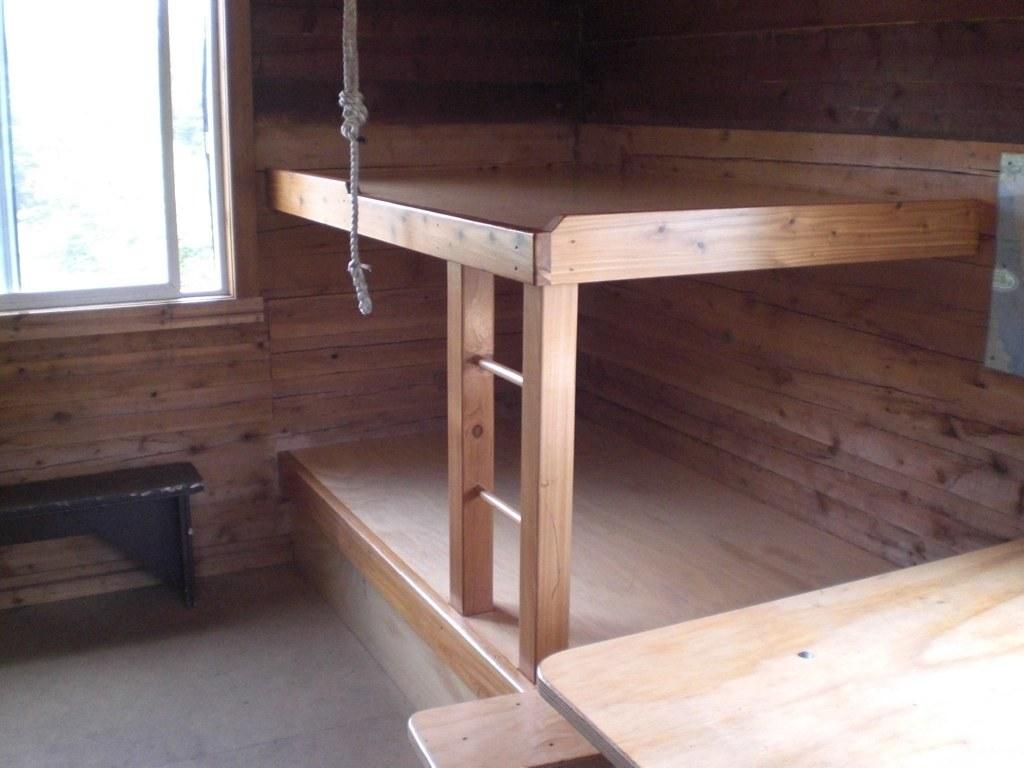What type of furniture is present in the image? There is a wooden bunk bed in the image. What other objects can be seen in the image? There are tables in the image. What part of the room is visible in the image? The floor is visible in the image. What can be seen in the background of the image? There is a window and a wall in the background of the image. What language is being spoken by the people in the image? There are no people visible in the image, so it is not possible to determine what language they might be speaking. 